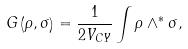Convert formula to latex. <formula><loc_0><loc_0><loc_500><loc_500>G \left ( { \rho , \sigma } \right ) = \frac { 1 } { { 2 V _ { C Y } } } \int { \rho \wedge ^ { * } \sigma } ,</formula> 